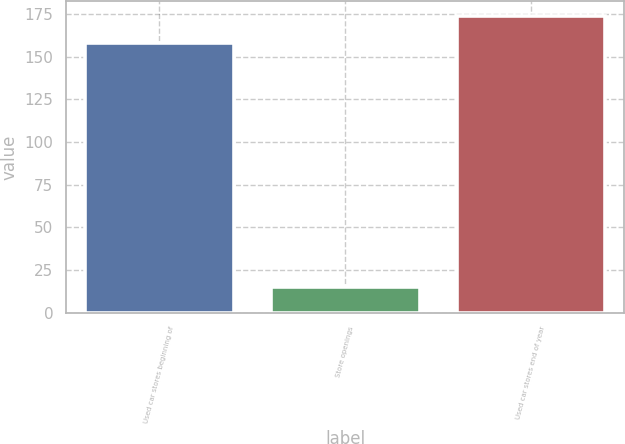<chart> <loc_0><loc_0><loc_500><loc_500><bar_chart><fcel>Used car stores beginning of<fcel>Store openings<fcel>Used car stores end of year<nl><fcel>158<fcel>15<fcel>173.8<nl></chart> 